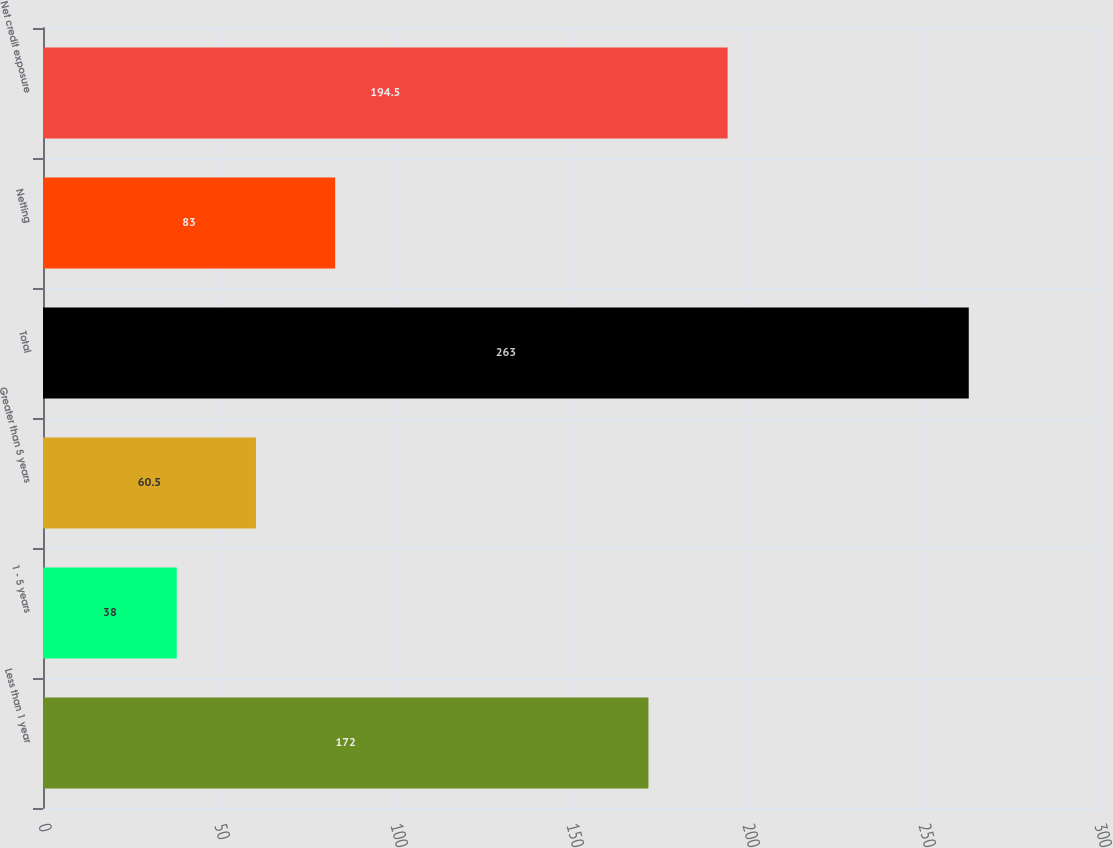<chart> <loc_0><loc_0><loc_500><loc_500><bar_chart><fcel>Less than 1 year<fcel>1 - 5 years<fcel>Greater than 5 years<fcel>Total<fcel>Netting<fcel>Net credit exposure<nl><fcel>172<fcel>38<fcel>60.5<fcel>263<fcel>83<fcel>194.5<nl></chart> 